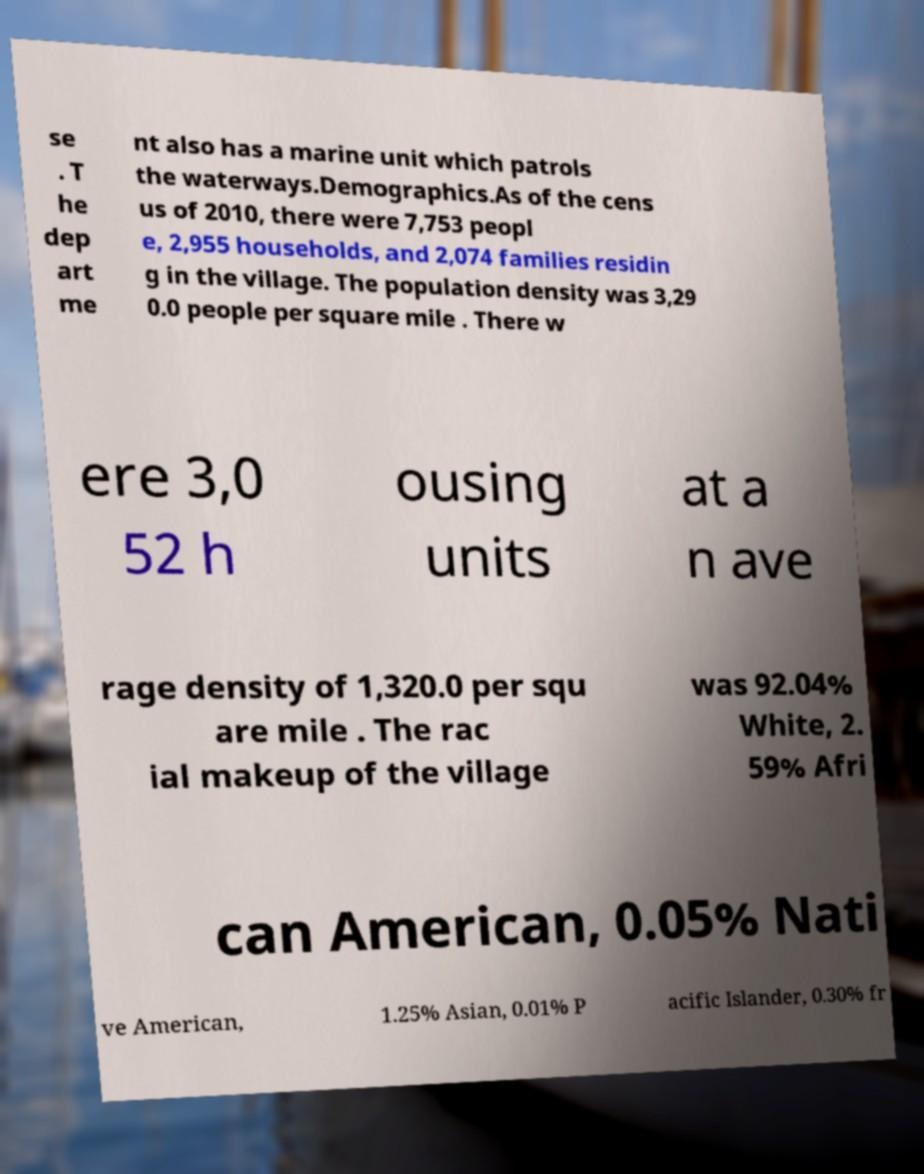Could you assist in decoding the text presented in this image and type it out clearly? se . T he dep art me nt also has a marine unit which patrols the waterways.Demographics.As of the cens us of 2010, there were 7,753 peopl e, 2,955 households, and 2,074 families residin g in the village. The population density was 3,29 0.0 people per square mile . There w ere 3,0 52 h ousing units at a n ave rage density of 1,320.0 per squ are mile . The rac ial makeup of the village was 92.04% White, 2. 59% Afri can American, 0.05% Nati ve American, 1.25% Asian, 0.01% P acific Islander, 0.30% fr 